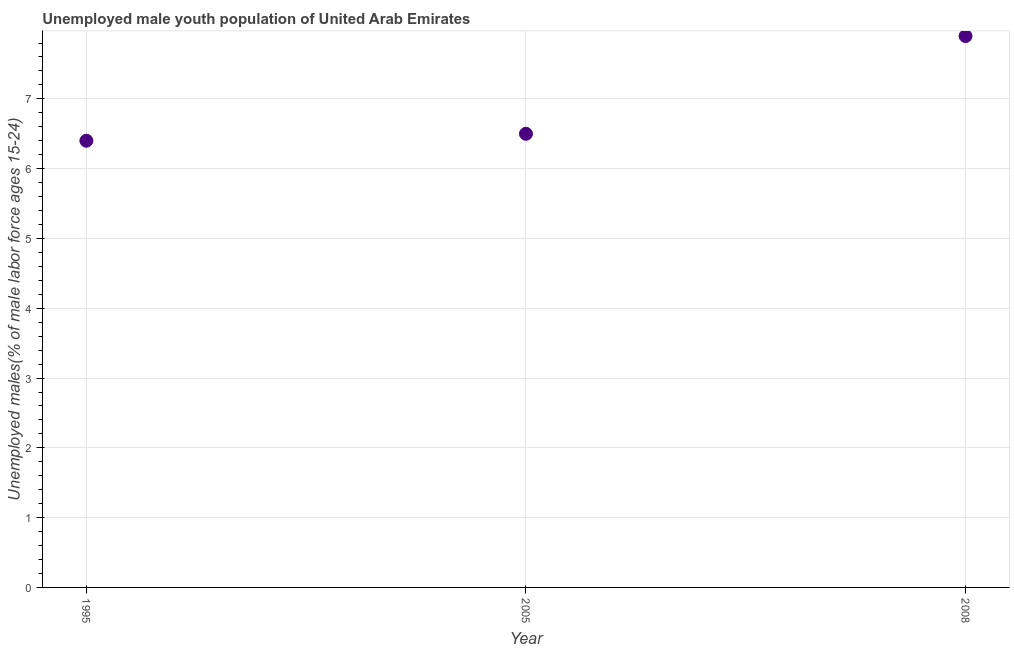What is the unemployed male youth in 1995?
Provide a succinct answer. 6.4. Across all years, what is the maximum unemployed male youth?
Give a very brief answer. 7.9. Across all years, what is the minimum unemployed male youth?
Provide a succinct answer. 6.4. What is the sum of the unemployed male youth?
Give a very brief answer. 20.8. What is the difference between the unemployed male youth in 1995 and 2005?
Provide a succinct answer. -0.1. What is the average unemployed male youth per year?
Provide a succinct answer. 6.93. What is the median unemployed male youth?
Your response must be concise. 6.5. Do a majority of the years between 1995 and 2005 (inclusive) have unemployed male youth greater than 2.4 %?
Provide a short and direct response. Yes. What is the ratio of the unemployed male youth in 1995 to that in 2008?
Provide a short and direct response. 0.81. Is the unemployed male youth in 2005 less than that in 2008?
Give a very brief answer. Yes. What is the difference between the highest and the second highest unemployed male youth?
Your response must be concise. 1.4. Is the sum of the unemployed male youth in 1995 and 2008 greater than the maximum unemployed male youth across all years?
Give a very brief answer. Yes. What is the difference between the highest and the lowest unemployed male youth?
Provide a short and direct response. 1.5. How many years are there in the graph?
Give a very brief answer. 3. What is the difference between two consecutive major ticks on the Y-axis?
Offer a terse response. 1. Are the values on the major ticks of Y-axis written in scientific E-notation?
Give a very brief answer. No. Does the graph contain any zero values?
Your answer should be compact. No. What is the title of the graph?
Keep it short and to the point. Unemployed male youth population of United Arab Emirates. What is the label or title of the X-axis?
Make the answer very short. Year. What is the label or title of the Y-axis?
Provide a short and direct response. Unemployed males(% of male labor force ages 15-24). What is the Unemployed males(% of male labor force ages 15-24) in 1995?
Provide a succinct answer. 6.4. What is the Unemployed males(% of male labor force ages 15-24) in 2005?
Offer a very short reply. 6.5. What is the Unemployed males(% of male labor force ages 15-24) in 2008?
Your answer should be compact. 7.9. What is the difference between the Unemployed males(% of male labor force ages 15-24) in 1995 and 2005?
Provide a short and direct response. -0.1. What is the difference between the Unemployed males(% of male labor force ages 15-24) in 1995 and 2008?
Give a very brief answer. -1.5. What is the ratio of the Unemployed males(% of male labor force ages 15-24) in 1995 to that in 2008?
Offer a terse response. 0.81. What is the ratio of the Unemployed males(% of male labor force ages 15-24) in 2005 to that in 2008?
Ensure brevity in your answer.  0.82. 